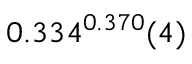<formula> <loc_0><loc_0><loc_500><loc_500>0 . 3 3 4 ^ { 0 . 3 7 0 } ( 4 )</formula> 